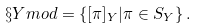<formula> <loc_0><loc_0><loc_500><loc_500>\S Y m o d = \{ [ \pi ] _ { Y } | \pi \in S _ { Y } \} \, .</formula> 